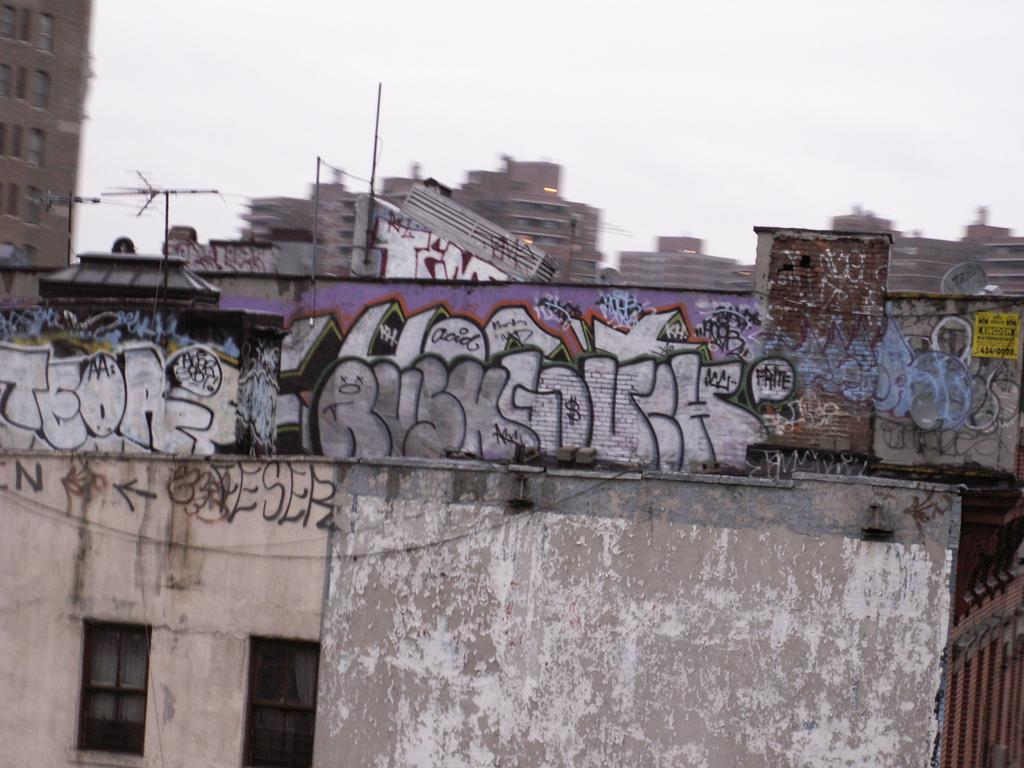What type of structures can be seen in the image? There are buildings in the image. What else is visible in the image besides the buildings? There are roads and graffiti on a wall in the image. How would you describe the sky in the image? The sky is cloudy in the image. What might be a reason for the blurry background in the image? The background of the image appears blurry, possibly due to a shallow depth of field or a moving subject. What type of van is the carpenter using to transport his tools in the image? There is no van or carpenter present in the image. What type of collar is the dog wearing in the image? There is no dog or collar present in the image. 